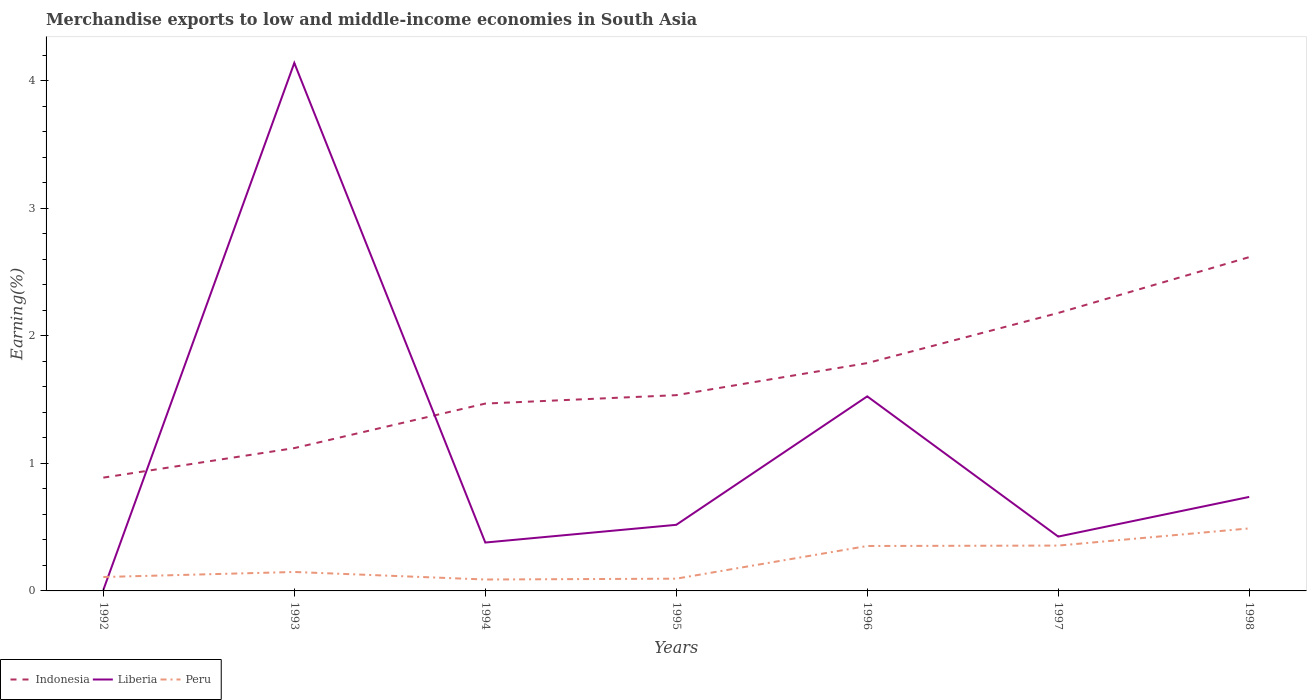How many different coloured lines are there?
Your answer should be compact. 3. Is the number of lines equal to the number of legend labels?
Make the answer very short. Yes. Across all years, what is the maximum percentage of amount earned from merchandise exports in Peru?
Your answer should be very brief. 0.09. In which year was the percentage of amount earned from merchandise exports in Indonesia maximum?
Ensure brevity in your answer.  1992. What is the total percentage of amount earned from merchandise exports in Liberia in the graph?
Offer a terse response. -0.05. What is the difference between the highest and the second highest percentage of amount earned from merchandise exports in Liberia?
Your response must be concise. 4.13. What is the difference between the highest and the lowest percentage of amount earned from merchandise exports in Liberia?
Provide a succinct answer. 2. How many years are there in the graph?
Your response must be concise. 7. What is the difference between two consecutive major ticks on the Y-axis?
Provide a short and direct response. 1. How many legend labels are there?
Offer a terse response. 3. What is the title of the graph?
Offer a terse response. Merchandise exports to low and middle-income economies in South Asia. Does "Sudan" appear as one of the legend labels in the graph?
Offer a very short reply. No. What is the label or title of the X-axis?
Your answer should be compact. Years. What is the label or title of the Y-axis?
Keep it short and to the point. Earning(%). What is the Earning(%) in Indonesia in 1992?
Offer a terse response. 0.89. What is the Earning(%) of Liberia in 1992?
Your answer should be compact. 0.01. What is the Earning(%) of Peru in 1992?
Provide a short and direct response. 0.11. What is the Earning(%) of Indonesia in 1993?
Offer a terse response. 1.12. What is the Earning(%) in Liberia in 1993?
Ensure brevity in your answer.  4.14. What is the Earning(%) of Peru in 1993?
Offer a terse response. 0.15. What is the Earning(%) of Indonesia in 1994?
Give a very brief answer. 1.47. What is the Earning(%) of Liberia in 1994?
Your answer should be very brief. 0.38. What is the Earning(%) of Peru in 1994?
Your response must be concise. 0.09. What is the Earning(%) in Indonesia in 1995?
Ensure brevity in your answer.  1.53. What is the Earning(%) in Liberia in 1995?
Ensure brevity in your answer.  0.52. What is the Earning(%) of Peru in 1995?
Your response must be concise. 0.1. What is the Earning(%) in Indonesia in 1996?
Ensure brevity in your answer.  1.79. What is the Earning(%) in Liberia in 1996?
Offer a very short reply. 1.53. What is the Earning(%) of Peru in 1996?
Your answer should be very brief. 0.35. What is the Earning(%) of Indonesia in 1997?
Provide a short and direct response. 2.18. What is the Earning(%) of Liberia in 1997?
Ensure brevity in your answer.  0.43. What is the Earning(%) in Peru in 1997?
Your response must be concise. 0.36. What is the Earning(%) of Indonesia in 1998?
Keep it short and to the point. 2.62. What is the Earning(%) in Liberia in 1998?
Provide a short and direct response. 0.74. What is the Earning(%) of Peru in 1998?
Keep it short and to the point. 0.49. Across all years, what is the maximum Earning(%) of Indonesia?
Offer a terse response. 2.62. Across all years, what is the maximum Earning(%) in Liberia?
Your answer should be very brief. 4.14. Across all years, what is the maximum Earning(%) of Peru?
Make the answer very short. 0.49. Across all years, what is the minimum Earning(%) of Indonesia?
Give a very brief answer. 0.89. Across all years, what is the minimum Earning(%) of Liberia?
Your response must be concise. 0.01. Across all years, what is the minimum Earning(%) in Peru?
Provide a short and direct response. 0.09. What is the total Earning(%) of Indonesia in the graph?
Provide a short and direct response. 11.59. What is the total Earning(%) in Liberia in the graph?
Offer a terse response. 7.73. What is the total Earning(%) of Peru in the graph?
Your answer should be compact. 1.64. What is the difference between the Earning(%) in Indonesia in 1992 and that in 1993?
Provide a short and direct response. -0.23. What is the difference between the Earning(%) of Liberia in 1992 and that in 1993?
Make the answer very short. -4.13. What is the difference between the Earning(%) of Peru in 1992 and that in 1993?
Give a very brief answer. -0.04. What is the difference between the Earning(%) of Indonesia in 1992 and that in 1994?
Ensure brevity in your answer.  -0.58. What is the difference between the Earning(%) of Liberia in 1992 and that in 1994?
Your answer should be very brief. -0.37. What is the difference between the Earning(%) in Peru in 1992 and that in 1994?
Offer a terse response. 0.02. What is the difference between the Earning(%) of Indonesia in 1992 and that in 1995?
Make the answer very short. -0.65. What is the difference between the Earning(%) of Liberia in 1992 and that in 1995?
Provide a short and direct response. -0.51. What is the difference between the Earning(%) in Peru in 1992 and that in 1995?
Make the answer very short. 0.01. What is the difference between the Earning(%) in Indonesia in 1992 and that in 1996?
Keep it short and to the point. -0.9. What is the difference between the Earning(%) of Liberia in 1992 and that in 1996?
Provide a short and direct response. -1.52. What is the difference between the Earning(%) of Peru in 1992 and that in 1996?
Keep it short and to the point. -0.24. What is the difference between the Earning(%) in Indonesia in 1992 and that in 1997?
Ensure brevity in your answer.  -1.29. What is the difference between the Earning(%) of Liberia in 1992 and that in 1997?
Offer a terse response. -0.42. What is the difference between the Earning(%) in Peru in 1992 and that in 1997?
Provide a short and direct response. -0.25. What is the difference between the Earning(%) in Indonesia in 1992 and that in 1998?
Provide a short and direct response. -1.73. What is the difference between the Earning(%) of Liberia in 1992 and that in 1998?
Make the answer very short. -0.73. What is the difference between the Earning(%) of Peru in 1992 and that in 1998?
Keep it short and to the point. -0.38. What is the difference between the Earning(%) of Indonesia in 1993 and that in 1994?
Offer a very short reply. -0.35. What is the difference between the Earning(%) of Liberia in 1993 and that in 1994?
Your answer should be compact. 3.76. What is the difference between the Earning(%) of Peru in 1993 and that in 1994?
Provide a short and direct response. 0.06. What is the difference between the Earning(%) of Indonesia in 1993 and that in 1995?
Offer a very short reply. -0.41. What is the difference between the Earning(%) in Liberia in 1993 and that in 1995?
Your response must be concise. 3.62. What is the difference between the Earning(%) in Peru in 1993 and that in 1995?
Provide a succinct answer. 0.05. What is the difference between the Earning(%) in Indonesia in 1993 and that in 1996?
Provide a short and direct response. -0.67. What is the difference between the Earning(%) of Liberia in 1993 and that in 1996?
Your answer should be compact. 2.61. What is the difference between the Earning(%) in Peru in 1993 and that in 1996?
Offer a terse response. -0.2. What is the difference between the Earning(%) in Indonesia in 1993 and that in 1997?
Offer a very short reply. -1.06. What is the difference between the Earning(%) in Liberia in 1993 and that in 1997?
Offer a terse response. 3.71. What is the difference between the Earning(%) of Peru in 1993 and that in 1997?
Your answer should be compact. -0.21. What is the difference between the Earning(%) of Indonesia in 1993 and that in 1998?
Your response must be concise. -1.5. What is the difference between the Earning(%) of Liberia in 1993 and that in 1998?
Provide a short and direct response. 3.4. What is the difference between the Earning(%) in Peru in 1993 and that in 1998?
Give a very brief answer. -0.34. What is the difference between the Earning(%) in Indonesia in 1994 and that in 1995?
Ensure brevity in your answer.  -0.07. What is the difference between the Earning(%) of Liberia in 1994 and that in 1995?
Ensure brevity in your answer.  -0.14. What is the difference between the Earning(%) of Peru in 1994 and that in 1995?
Your answer should be compact. -0.01. What is the difference between the Earning(%) of Indonesia in 1994 and that in 1996?
Your answer should be very brief. -0.32. What is the difference between the Earning(%) in Liberia in 1994 and that in 1996?
Offer a very short reply. -1.15. What is the difference between the Earning(%) in Peru in 1994 and that in 1996?
Offer a very short reply. -0.26. What is the difference between the Earning(%) in Indonesia in 1994 and that in 1997?
Provide a succinct answer. -0.71. What is the difference between the Earning(%) in Liberia in 1994 and that in 1997?
Offer a terse response. -0.05. What is the difference between the Earning(%) in Peru in 1994 and that in 1997?
Provide a short and direct response. -0.27. What is the difference between the Earning(%) of Indonesia in 1994 and that in 1998?
Ensure brevity in your answer.  -1.15. What is the difference between the Earning(%) of Liberia in 1994 and that in 1998?
Provide a short and direct response. -0.36. What is the difference between the Earning(%) of Peru in 1994 and that in 1998?
Your response must be concise. -0.4. What is the difference between the Earning(%) in Indonesia in 1995 and that in 1996?
Make the answer very short. -0.25. What is the difference between the Earning(%) in Liberia in 1995 and that in 1996?
Provide a short and direct response. -1.01. What is the difference between the Earning(%) in Peru in 1995 and that in 1996?
Make the answer very short. -0.26. What is the difference between the Earning(%) of Indonesia in 1995 and that in 1997?
Provide a succinct answer. -0.64. What is the difference between the Earning(%) of Liberia in 1995 and that in 1997?
Ensure brevity in your answer.  0.09. What is the difference between the Earning(%) of Peru in 1995 and that in 1997?
Offer a terse response. -0.26. What is the difference between the Earning(%) in Indonesia in 1995 and that in 1998?
Keep it short and to the point. -1.08. What is the difference between the Earning(%) in Liberia in 1995 and that in 1998?
Keep it short and to the point. -0.22. What is the difference between the Earning(%) of Peru in 1995 and that in 1998?
Provide a short and direct response. -0.39. What is the difference between the Earning(%) in Indonesia in 1996 and that in 1997?
Provide a short and direct response. -0.39. What is the difference between the Earning(%) in Liberia in 1996 and that in 1997?
Offer a very short reply. 1.1. What is the difference between the Earning(%) in Peru in 1996 and that in 1997?
Ensure brevity in your answer.  -0. What is the difference between the Earning(%) in Indonesia in 1996 and that in 1998?
Keep it short and to the point. -0.83. What is the difference between the Earning(%) in Liberia in 1996 and that in 1998?
Your answer should be compact. 0.79. What is the difference between the Earning(%) of Peru in 1996 and that in 1998?
Your answer should be compact. -0.14. What is the difference between the Earning(%) of Indonesia in 1997 and that in 1998?
Give a very brief answer. -0.44. What is the difference between the Earning(%) in Liberia in 1997 and that in 1998?
Provide a succinct answer. -0.31. What is the difference between the Earning(%) in Peru in 1997 and that in 1998?
Make the answer very short. -0.13. What is the difference between the Earning(%) of Indonesia in 1992 and the Earning(%) of Liberia in 1993?
Keep it short and to the point. -3.25. What is the difference between the Earning(%) of Indonesia in 1992 and the Earning(%) of Peru in 1993?
Give a very brief answer. 0.74. What is the difference between the Earning(%) of Liberia in 1992 and the Earning(%) of Peru in 1993?
Give a very brief answer. -0.14. What is the difference between the Earning(%) in Indonesia in 1992 and the Earning(%) in Liberia in 1994?
Offer a very short reply. 0.51. What is the difference between the Earning(%) in Indonesia in 1992 and the Earning(%) in Peru in 1994?
Make the answer very short. 0.8. What is the difference between the Earning(%) in Liberia in 1992 and the Earning(%) in Peru in 1994?
Provide a short and direct response. -0.08. What is the difference between the Earning(%) in Indonesia in 1992 and the Earning(%) in Liberia in 1995?
Offer a very short reply. 0.37. What is the difference between the Earning(%) of Indonesia in 1992 and the Earning(%) of Peru in 1995?
Ensure brevity in your answer.  0.79. What is the difference between the Earning(%) of Liberia in 1992 and the Earning(%) of Peru in 1995?
Provide a succinct answer. -0.09. What is the difference between the Earning(%) in Indonesia in 1992 and the Earning(%) in Liberia in 1996?
Give a very brief answer. -0.64. What is the difference between the Earning(%) of Indonesia in 1992 and the Earning(%) of Peru in 1996?
Your answer should be compact. 0.54. What is the difference between the Earning(%) in Liberia in 1992 and the Earning(%) in Peru in 1996?
Make the answer very short. -0.34. What is the difference between the Earning(%) of Indonesia in 1992 and the Earning(%) of Liberia in 1997?
Make the answer very short. 0.46. What is the difference between the Earning(%) in Indonesia in 1992 and the Earning(%) in Peru in 1997?
Offer a terse response. 0.53. What is the difference between the Earning(%) in Liberia in 1992 and the Earning(%) in Peru in 1997?
Keep it short and to the point. -0.35. What is the difference between the Earning(%) in Indonesia in 1992 and the Earning(%) in Liberia in 1998?
Your response must be concise. 0.15. What is the difference between the Earning(%) of Indonesia in 1992 and the Earning(%) of Peru in 1998?
Keep it short and to the point. 0.4. What is the difference between the Earning(%) in Liberia in 1992 and the Earning(%) in Peru in 1998?
Offer a very short reply. -0.48. What is the difference between the Earning(%) of Indonesia in 1993 and the Earning(%) of Liberia in 1994?
Your answer should be very brief. 0.74. What is the difference between the Earning(%) in Indonesia in 1993 and the Earning(%) in Peru in 1994?
Ensure brevity in your answer.  1.03. What is the difference between the Earning(%) of Liberia in 1993 and the Earning(%) of Peru in 1994?
Keep it short and to the point. 4.05. What is the difference between the Earning(%) of Indonesia in 1993 and the Earning(%) of Liberia in 1995?
Provide a short and direct response. 0.6. What is the difference between the Earning(%) in Indonesia in 1993 and the Earning(%) in Peru in 1995?
Ensure brevity in your answer.  1.02. What is the difference between the Earning(%) of Liberia in 1993 and the Earning(%) of Peru in 1995?
Provide a short and direct response. 4.04. What is the difference between the Earning(%) in Indonesia in 1993 and the Earning(%) in Liberia in 1996?
Keep it short and to the point. -0.41. What is the difference between the Earning(%) of Indonesia in 1993 and the Earning(%) of Peru in 1996?
Provide a short and direct response. 0.77. What is the difference between the Earning(%) in Liberia in 1993 and the Earning(%) in Peru in 1996?
Offer a very short reply. 3.79. What is the difference between the Earning(%) in Indonesia in 1993 and the Earning(%) in Liberia in 1997?
Provide a succinct answer. 0.69. What is the difference between the Earning(%) of Indonesia in 1993 and the Earning(%) of Peru in 1997?
Offer a very short reply. 0.76. What is the difference between the Earning(%) of Liberia in 1993 and the Earning(%) of Peru in 1997?
Your answer should be very brief. 3.78. What is the difference between the Earning(%) of Indonesia in 1993 and the Earning(%) of Liberia in 1998?
Offer a very short reply. 0.38. What is the difference between the Earning(%) in Indonesia in 1993 and the Earning(%) in Peru in 1998?
Ensure brevity in your answer.  0.63. What is the difference between the Earning(%) in Liberia in 1993 and the Earning(%) in Peru in 1998?
Make the answer very short. 3.65. What is the difference between the Earning(%) of Indonesia in 1994 and the Earning(%) of Liberia in 1995?
Provide a short and direct response. 0.95. What is the difference between the Earning(%) of Indonesia in 1994 and the Earning(%) of Peru in 1995?
Offer a terse response. 1.37. What is the difference between the Earning(%) in Liberia in 1994 and the Earning(%) in Peru in 1995?
Ensure brevity in your answer.  0.28. What is the difference between the Earning(%) in Indonesia in 1994 and the Earning(%) in Liberia in 1996?
Offer a very short reply. -0.06. What is the difference between the Earning(%) in Indonesia in 1994 and the Earning(%) in Peru in 1996?
Give a very brief answer. 1.12. What is the difference between the Earning(%) of Liberia in 1994 and the Earning(%) of Peru in 1996?
Ensure brevity in your answer.  0.03. What is the difference between the Earning(%) of Indonesia in 1994 and the Earning(%) of Liberia in 1997?
Your response must be concise. 1.04. What is the difference between the Earning(%) in Indonesia in 1994 and the Earning(%) in Peru in 1997?
Keep it short and to the point. 1.11. What is the difference between the Earning(%) in Liberia in 1994 and the Earning(%) in Peru in 1997?
Make the answer very short. 0.02. What is the difference between the Earning(%) of Indonesia in 1994 and the Earning(%) of Liberia in 1998?
Make the answer very short. 0.73. What is the difference between the Earning(%) in Indonesia in 1994 and the Earning(%) in Peru in 1998?
Offer a terse response. 0.98. What is the difference between the Earning(%) in Liberia in 1994 and the Earning(%) in Peru in 1998?
Keep it short and to the point. -0.11. What is the difference between the Earning(%) of Indonesia in 1995 and the Earning(%) of Liberia in 1996?
Provide a short and direct response. 0.01. What is the difference between the Earning(%) in Indonesia in 1995 and the Earning(%) in Peru in 1996?
Give a very brief answer. 1.18. What is the difference between the Earning(%) in Liberia in 1995 and the Earning(%) in Peru in 1996?
Give a very brief answer. 0.17. What is the difference between the Earning(%) in Indonesia in 1995 and the Earning(%) in Liberia in 1997?
Your answer should be compact. 1.11. What is the difference between the Earning(%) in Indonesia in 1995 and the Earning(%) in Peru in 1997?
Offer a very short reply. 1.18. What is the difference between the Earning(%) of Liberia in 1995 and the Earning(%) of Peru in 1997?
Provide a short and direct response. 0.16. What is the difference between the Earning(%) in Indonesia in 1995 and the Earning(%) in Liberia in 1998?
Ensure brevity in your answer.  0.8. What is the difference between the Earning(%) of Indonesia in 1995 and the Earning(%) of Peru in 1998?
Provide a succinct answer. 1.04. What is the difference between the Earning(%) of Liberia in 1995 and the Earning(%) of Peru in 1998?
Offer a terse response. 0.03. What is the difference between the Earning(%) in Indonesia in 1996 and the Earning(%) in Liberia in 1997?
Ensure brevity in your answer.  1.36. What is the difference between the Earning(%) of Indonesia in 1996 and the Earning(%) of Peru in 1997?
Keep it short and to the point. 1.43. What is the difference between the Earning(%) in Liberia in 1996 and the Earning(%) in Peru in 1997?
Keep it short and to the point. 1.17. What is the difference between the Earning(%) of Indonesia in 1996 and the Earning(%) of Liberia in 1998?
Your answer should be very brief. 1.05. What is the difference between the Earning(%) in Indonesia in 1996 and the Earning(%) in Peru in 1998?
Your answer should be compact. 1.3. What is the difference between the Earning(%) in Liberia in 1996 and the Earning(%) in Peru in 1998?
Provide a succinct answer. 1.04. What is the difference between the Earning(%) of Indonesia in 1997 and the Earning(%) of Liberia in 1998?
Give a very brief answer. 1.44. What is the difference between the Earning(%) of Indonesia in 1997 and the Earning(%) of Peru in 1998?
Your response must be concise. 1.69. What is the difference between the Earning(%) in Liberia in 1997 and the Earning(%) in Peru in 1998?
Offer a terse response. -0.06. What is the average Earning(%) of Indonesia per year?
Your response must be concise. 1.66. What is the average Earning(%) of Liberia per year?
Keep it short and to the point. 1.1. What is the average Earning(%) in Peru per year?
Offer a terse response. 0.23. In the year 1992, what is the difference between the Earning(%) of Indonesia and Earning(%) of Liberia?
Offer a terse response. 0.88. In the year 1992, what is the difference between the Earning(%) of Indonesia and Earning(%) of Peru?
Give a very brief answer. 0.78. In the year 1992, what is the difference between the Earning(%) in Liberia and Earning(%) in Peru?
Provide a succinct answer. -0.1. In the year 1993, what is the difference between the Earning(%) in Indonesia and Earning(%) in Liberia?
Provide a short and direct response. -3.02. In the year 1993, what is the difference between the Earning(%) in Indonesia and Earning(%) in Peru?
Your answer should be compact. 0.97. In the year 1993, what is the difference between the Earning(%) of Liberia and Earning(%) of Peru?
Your response must be concise. 3.99. In the year 1994, what is the difference between the Earning(%) of Indonesia and Earning(%) of Liberia?
Make the answer very short. 1.09. In the year 1994, what is the difference between the Earning(%) of Indonesia and Earning(%) of Peru?
Offer a terse response. 1.38. In the year 1994, what is the difference between the Earning(%) of Liberia and Earning(%) of Peru?
Keep it short and to the point. 0.29. In the year 1995, what is the difference between the Earning(%) in Indonesia and Earning(%) in Liberia?
Offer a very short reply. 1.02. In the year 1995, what is the difference between the Earning(%) in Indonesia and Earning(%) in Peru?
Provide a succinct answer. 1.44. In the year 1995, what is the difference between the Earning(%) of Liberia and Earning(%) of Peru?
Provide a short and direct response. 0.42. In the year 1996, what is the difference between the Earning(%) in Indonesia and Earning(%) in Liberia?
Your answer should be compact. 0.26. In the year 1996, what is the difference between the Earning(%) of Indonesia and Earning(%) of Peru?
Offer a terse response. 1.43. In the year 1996, what is the difference between the Earning(%) in Liberia and Earning(%) in Peru?
Give a very brief answer. 1.17. In the year 1997, what is the difference between the Earning(%) of Indonesia and Earning(%) of Liberia?
Offer a very short reply. 1.75. In the year 1997, what is the difference between the Earning(%) in Indonesia and Earning(%) in Peru?
Offer a terse response. 1.82. In the year 1997, what is the difference between the Earning(%) of Liberia and Earning(%) of Peru?
Provide a short and direct response. 0.07. In the year 1998, what is the difference between the Earning(%) in Indonesia and Earning(%) in Liberia?
Make the answer very short. 1.88. In the year 1998, what is the difference between the Earning(%) of Indonesia and Earning(%) of Peru?
Offer a very short reply. 2.13. In the year 1998, what is the difference between the Earning(%) in Liberia and Earning(%) in Peru?
Ensure brevity in your answer.  0.25. What is the ratio of the Earning(%) of Indonesia in 1992 to that in 1993?
Offer a very short reply. 0.79. What is the ratio of the Earning(%) of Liberia in 1992 to that in 1993?
Keep it short and to the point. 0. What is the ratio of the Earning(%) in Peru in 1992 to that in 1993?
Provide a succinct answer. 0.73. What is the ratio of the Earning(%) of Indonesia in 1992 to that in 1994?
Your answer should be very brief. 0.6. What is the ratio of the Earning(%) of Liberia in 1992 to that in 1994?
Keep it short and to the point. 0.02. What is the ratio of the Earning(%) in Peru in 1992 to that in 1994?
Your response must be concise. 1.22. What is the ratio of the Earning(%) of Indonesia in 1992 to that in 1995?
Your response must be concise. 0.58. What is the ratio of the Earning(%) of Liberia in 1992 to that in 1995?
Offer a terse response. 0.01. What is the ratio of the Earning(%) of Peru in 1992 to that in 1995?
Ensure brevity in your answer.  1.14. What is the ratio of the Earning(%) of Indonesia in 1992 to that in 1996?
Offer a very short reply. 0.5. What is the ratio of the Earning(%) of Liberia in 1992 to that in 1996?
Provide a succinct answer. 0.01. What is the ratio of the Earning(%) in Peru in 1992 to that in 1996?
Provide a succinct answer. 0.31. What is the ratio of the Earning(%) of Indonesia in 1992 to that in 1997?
Give a very brief answer. 0.41. What is the ratio of the Earning(%) in Liberia in 1992 to that in 1997?
Your response must be concise. 0.02. What is the ratio of the Earning(%) of Peru in 1992 to that in 1997?
Provide a short and direct response. 0.31. What is the ratio of the Earning(%) of Indonesia in 1992 to that in 1998?
Offer a very short reply. 0.34. What is the ratio of the Earning(%) in Liberia in 1992 to that in 1998?
Make the answer very short. 0.01. What is the ratio of the Earning(%) in Peru in 1992 to that in 1998?
Ensure brevity in your answer.  0.22. What is the ratio of the Earning(%) in Indonesia in 1993 to that in 1994?
Your answer should be compact. 0.76. What is the ratio of the Earning(%) in Liberia in 1993 to that in 1994?
Your answer should be compact. 10.91. What is the ratio of the Earning(%) in Peru in 1993 to that in 1994?
Offer a very short reply. 1.66. What is the ratio of the Earning(%) in Indonesia in 1993 to that in 1995?
Give a very brief answer. 0.73. What is the ratio of the Earning(%) of Liberia in 1993 to that in 1995?
Offer a very short reply. 7.99. What is the ratio of the Earning(%) in Peru in 1993 to that in 1995?
Keep it short and to the point. 1.55. What is the ratio of the Earning(%) of Indonesia in 1993 to that in 1996?
Provide a short and direct response. 0.63. What is the ratio of the Earning(%) in Liberia in 1993 to that in 1996?
Make the answer very short. 2.71. What is the ratio of the Earning(%) of Peru in 1993 to that in 1996?
Give a very brief answer. 0.42. What is the ratio of the Earning(%) in Indonesia in 1993 to that in 1997?
Offer a very short reply. 0.51. What is the ratio of the Earning(%) in Liberia in 1993 to that in 1997?
Provide a short and direct response. 9.72. What is the ratio of the Earning(%) of Peru in 1993 to that in 1997?
Your answer should be compact. 0.42. What is the ratio of the Earning(%) of Indonesia in 1993 to that in 1998?
Provide a short and direct response. 0.43. What is the ratio of the Earning(%) in Liberia in 1993 to that in 1998?
Make the answer very short. 5.62. What is the ratio of the Earning(%) of Peru in 1993 to that in 1998?
Your answer should be very brief. 0.3. What is the ratio of the Earning(%) of Indonesia in 1994 to that in 1995?
Give a very brief answer. 0.96. What is the ratio of the Earning(%) of Liberia in 1994 to that in 1995?
Offer a terse response. 0.73. What is the ratio of the Earning(%) in Peru in 1994 to that in 1995?
Offer a terse response. 0.93. What is the ratio of the Earning(%) of Indonesia in 1994 to that in 1996?
Ensure brevity in your answer.  0.82. What is the ratio of the Earning(%) of Liberia in 1994 to that in 1996?
Ensure brevity in your answer.  0.25. What is the ratio of the Earning(%) in Peru in 1994 to that in 1996?
Offer a terse response. 0.25. What is the ratio of the Earning(%) in Indonesia in 1994 to that in 1997?
Offer a terse response. 0.67. What is the ratio of the Earning(%) in Liberia in 1994 to that in 1997?
Your answer should be very brief. 0.89. What is the ratio of the Earning(%) of Peru in 1994 to that in 1997?
Your answer should be very brief. 0.25. What is the ratio of the Earning(%) of Indonesia in 1994 to that in 1998?
Your response must be concise. 0.56. What is the ratio of the Earning(%) in Liberia in 1994 to that in 1998?
Make the answer very short. 0.51. What is the ratio of the Earning(%) of Peru in 1994 to that in 1998?
Your response must be concise. 0.18. What is the ratio of the Earning(%) in Indonesia in 1995 to that in 1996?
Provide a short and direct response. 0.86. What is the ratio of the Earning(%) of Liberia in 1995 to that in 1996?
Ensure brevity in your answer.  0.34. What is the ratio of the Earning(%) of Peru in 1995 to that in 1996?
Your answer should be very brief. 0.27. What is the ratio of the Earning(%) in Indonesia in 1995 to that in 1997?
Ensure brevity in your answer.  0.7. What is the ratio of the Earning(%) in Liberia in 1995 to that in 1997?
Your answer should be very brief. 1.22. What is the ratio of the Earning(%) in Peru in 1995 to that in 1997?
Keep it short and to the point. 0.27. What is the ratio of the Earning(%) in Indonesia in 1995 to that in 1998?
Provide a short and direct response. 0.59. What is the ratio of the Earning(%) of Liberia in 1995 to that in 1998?
Your answer should be compact. 0.7. What is the ratio of the Earning(%) in Peru in 1995 to that in 1998?
Provide a short and direct response. 0.2. What is the ratio of the Earning(%) of Indonesia in 1996 to that in 1997?
Your response must be concise. 0.82. What is the ratio of the Earning(%) in Liberia in 1996 to that in 1997?
Make the answer very short. 3.58. What is the ratio of the Earning(%) in Indonesia in 1996 to that in 1998?
Ensure brevity in your answer.  0.68. What is the ratio of the Earning(%) of Liberia in 1996 to that in 1998?
Your answer should be very brief. 2.07. What is the ratio of the Earning(%) in Peru in 1996 to that in 1998?
Your answer should be very brief. 0.72. What is the ratio of the Earning(%) in Indonesia in 1997 to that in 1998?
Offer a very short reply. 0.83. What is the ratio of the Earning(%) of Liberia in 1997 to that in 1998?
Give a very brief answer. 0.58. What is the ratio of the Earning(%) in Peru in 1997 to that in 1998?
Provide a succinct answer. 0.73. What is the difference between the highest and the second highest Earning(%) of Indonesia?
Your answer should be very brief. 0.44. What is the difference between the highest and the second highest Earning(%) in Liberia?
Your answer should be compact. 2.61. What is the difference between the highest and the second highest Earning(%) of Peru?
Give a very brief answer. 0.13. What is the difference between the highest and the lowest Earning(%) of Indonesia?
Your response must be concise. 1.73. What is the difference between the highest and the lowest Earning(%) in Liberia?
Offer a terse response. 4.13. What is the difference between the highest and the lowest Earning(%) in Peru?
Your answer should be very brief. 0.4. 